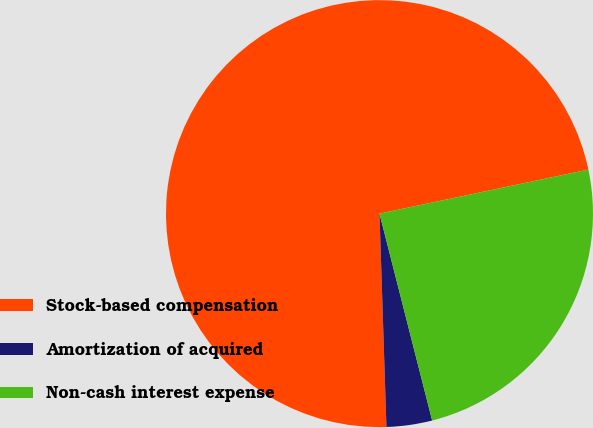Convert chart. <chart><loc_0><loc_0><loc_500><loc_500><pie_chart><fcel>Stock-based compensation<fcel>Amortization of acquired<fcel>Non-cash interest expense<nl><fcel>72.21%<fcel>3.45%<fcel>24.34%<nl></chart> 